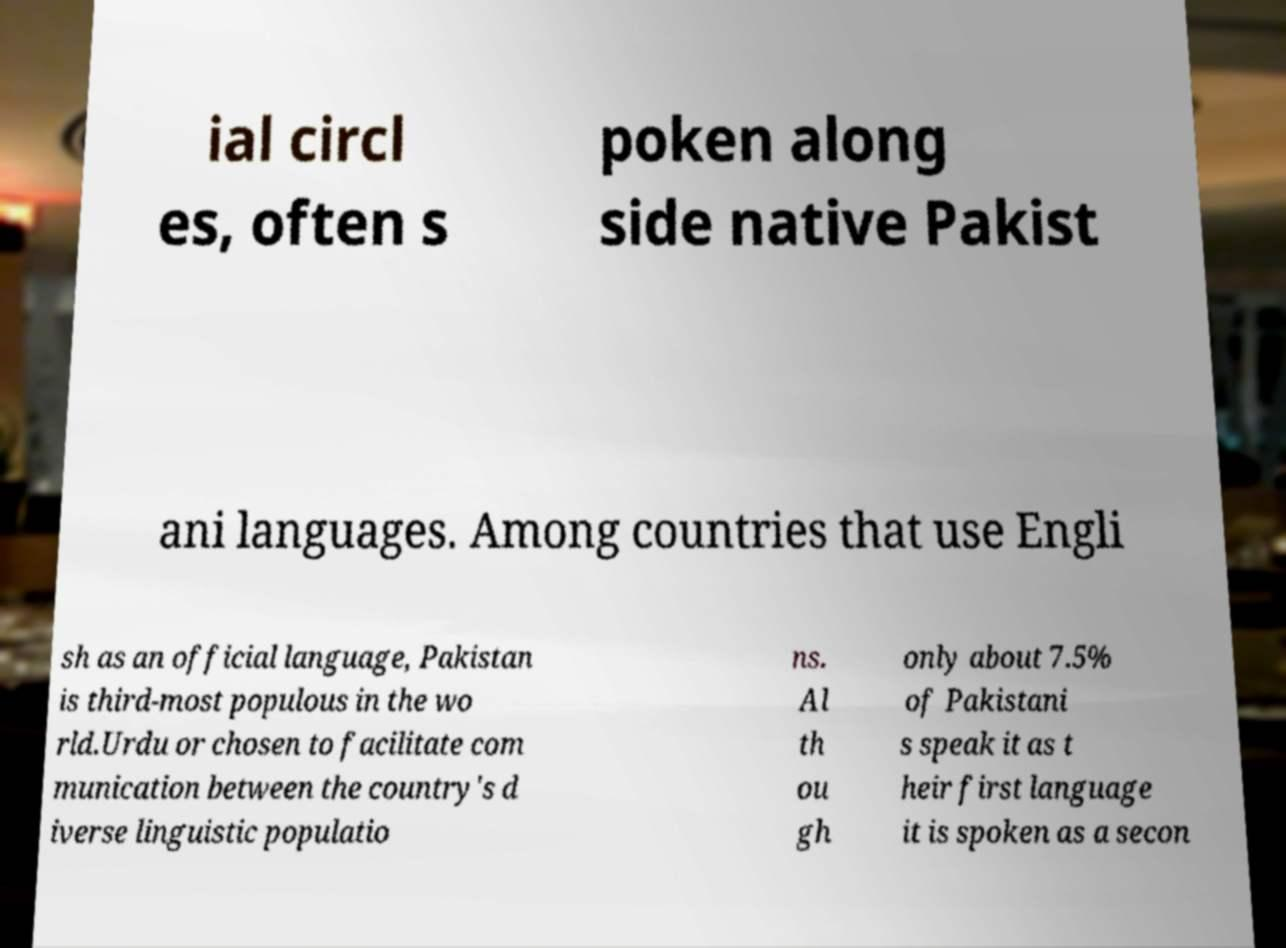Please read and relay the text visible in this image. What does it say? ial circl es, often s poken along side native Pakist ani languages. Among countries that use Engli sh as an official language, Pakistan is third-most populous in the wo rld.Urdu or chosen to facilitate com munication between the country's d iverse linguistic populatio ns. Al th ou gh only about 7.5% of Pakistani s speak it as t heir first language it is spoken as a secon 